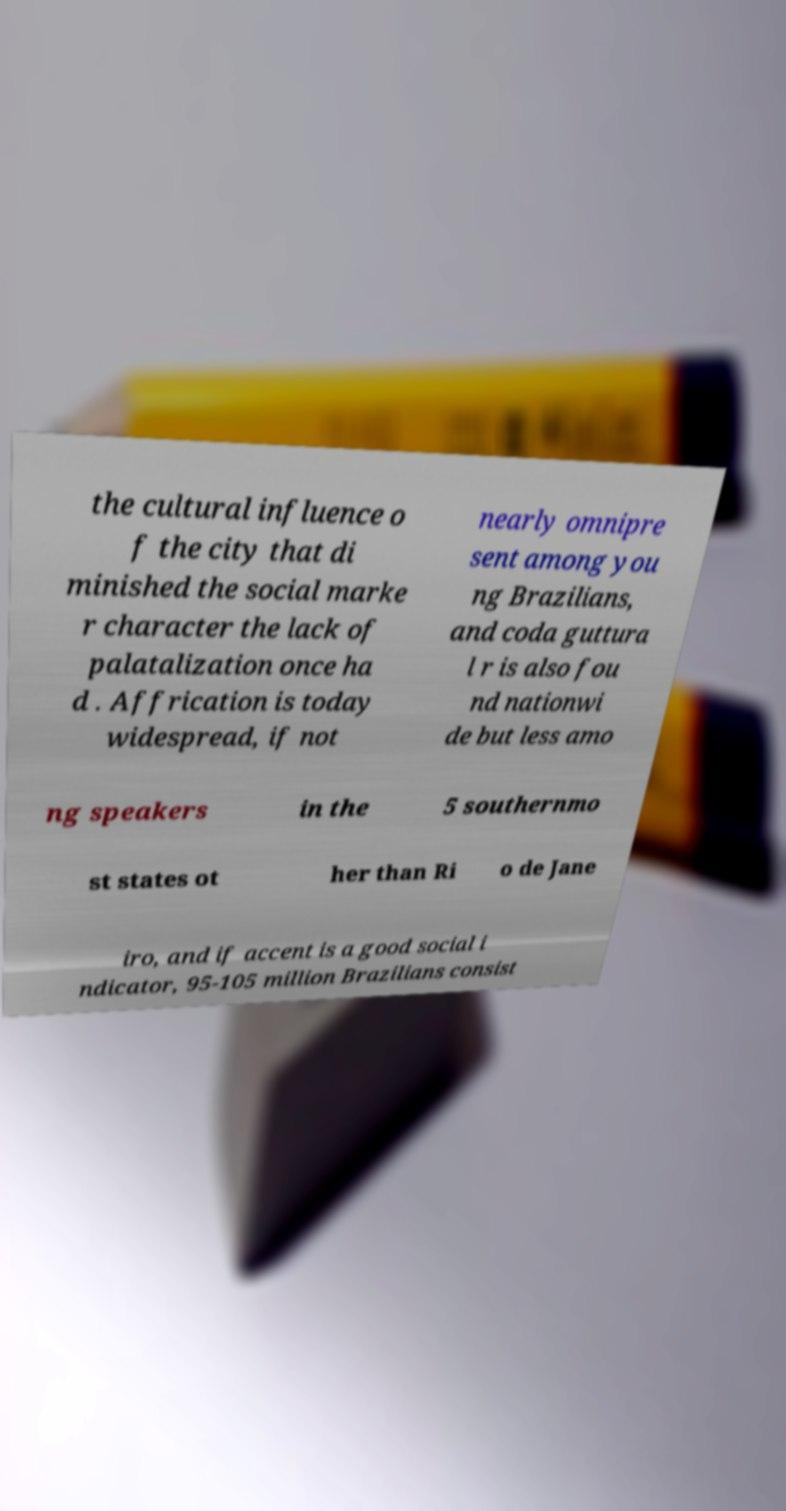Could you extract and type out the text from this image? the cultural influence o f the city that di minished the social marke r character the lack of palatalization once ha d . Affrication is today widespread, if not nearly omnipre sent among you ng Brazilians, and coda guttura l r is also fou nd nationwi de but less amo ng speakers in the 5 southernmo st states ot her than Ri o de Jane iro, and if accent is a good social i ndicator, 95-105 million Brazilians consist 